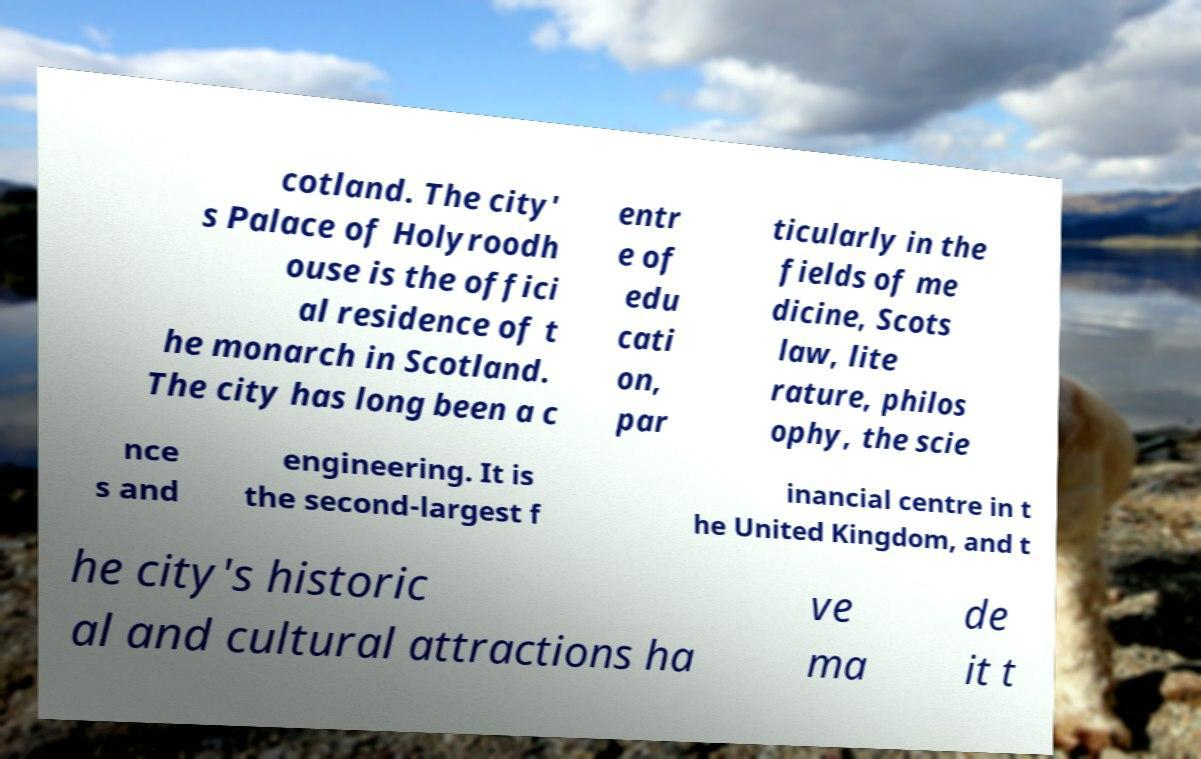Could you assist in decoding the text presented in this image and type it out clearly? cotland. The city' s Palace of Holyroodh ouse is the offici al residence of t he monarch in Scotland. The city has long been a c entr e of edu cati on, par ticularly in the fields of me dicine, Scots law, lite rature, philos ophy, the scie nce s and engineering. It is the second-largest f inancial centre in t he United Kingdom, and t he city's historic al and cultural attractions ha ve ma de it t 